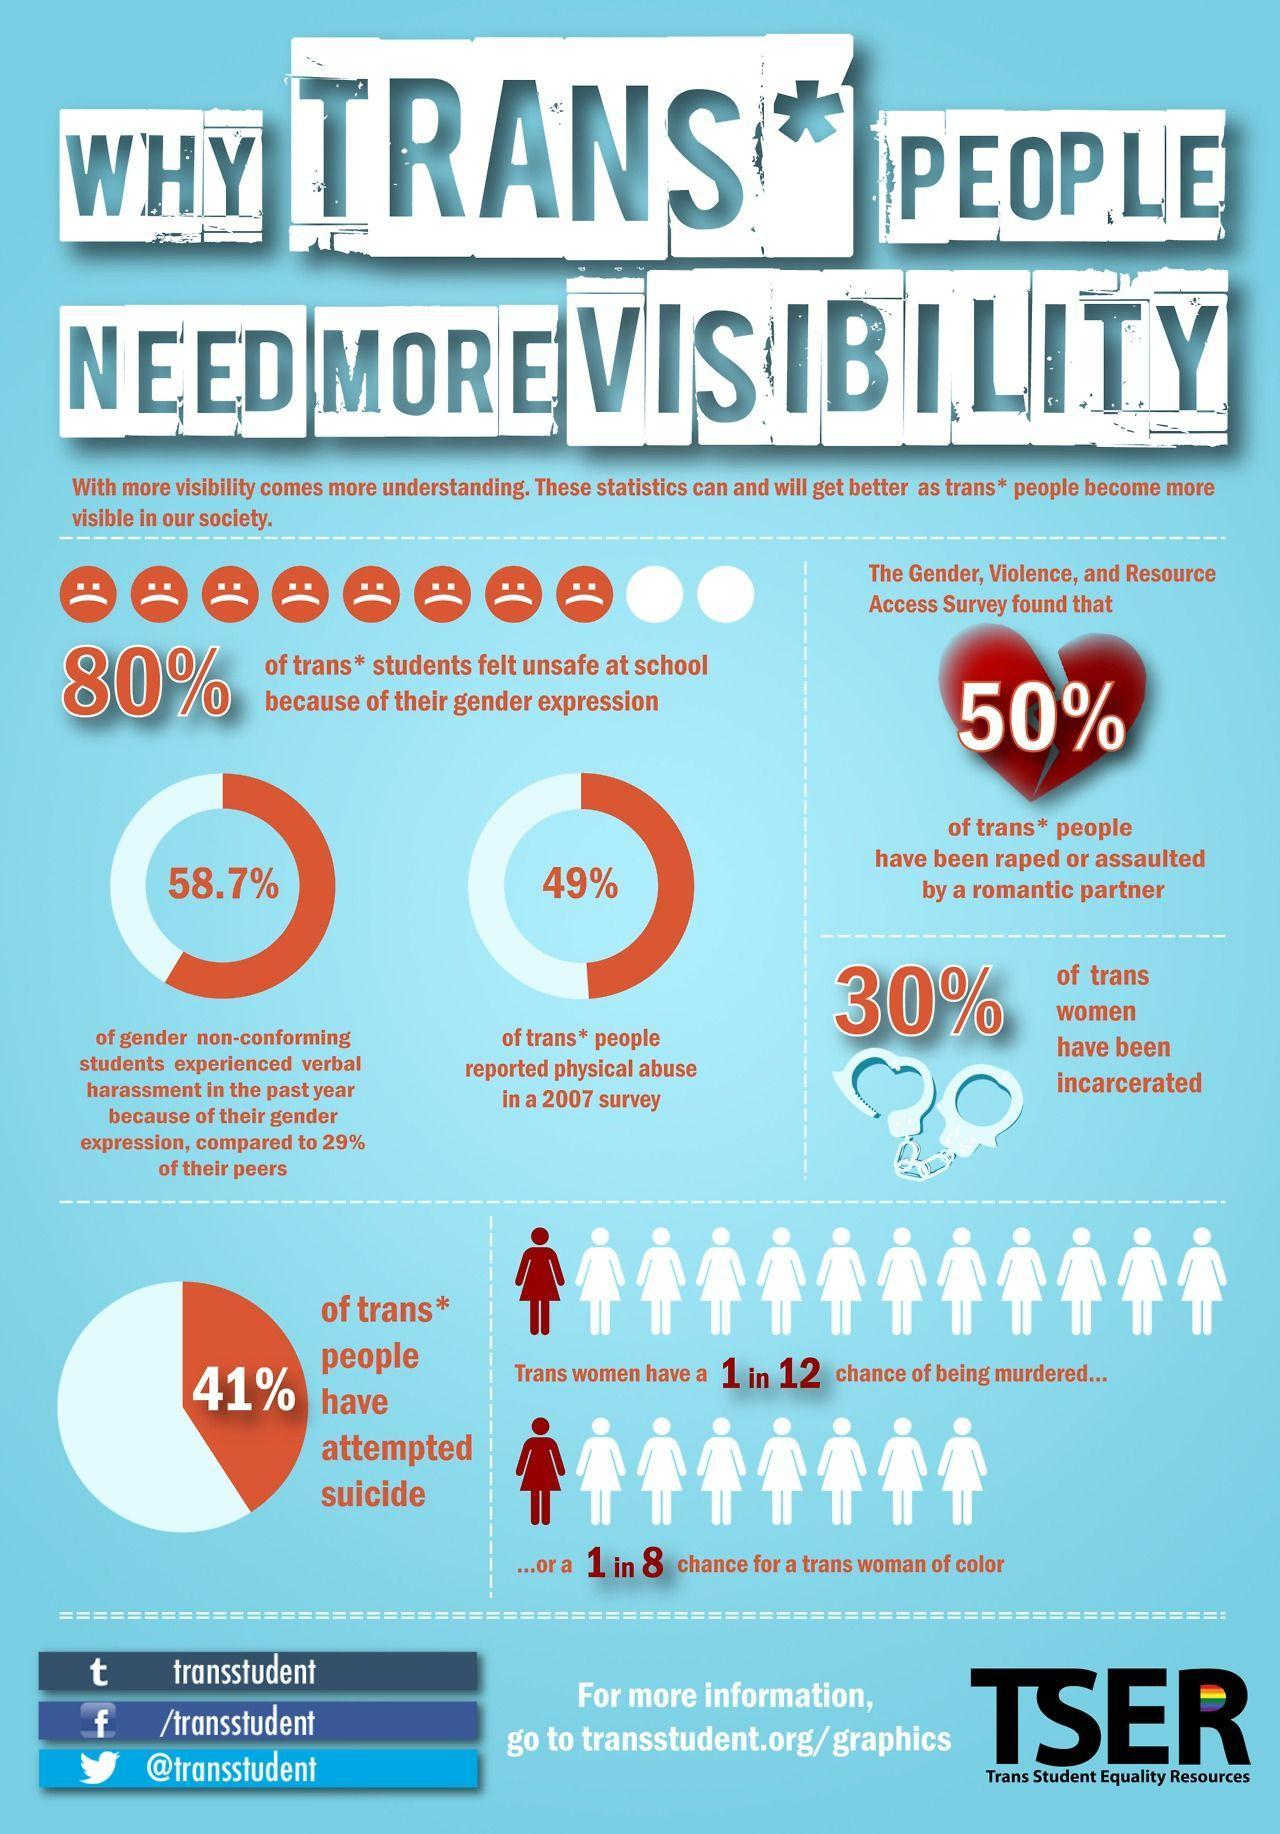What is the Twitter handle given?
Answer the question with a short phrase. @transstudent Which Facebook profile is given? /transstudent 